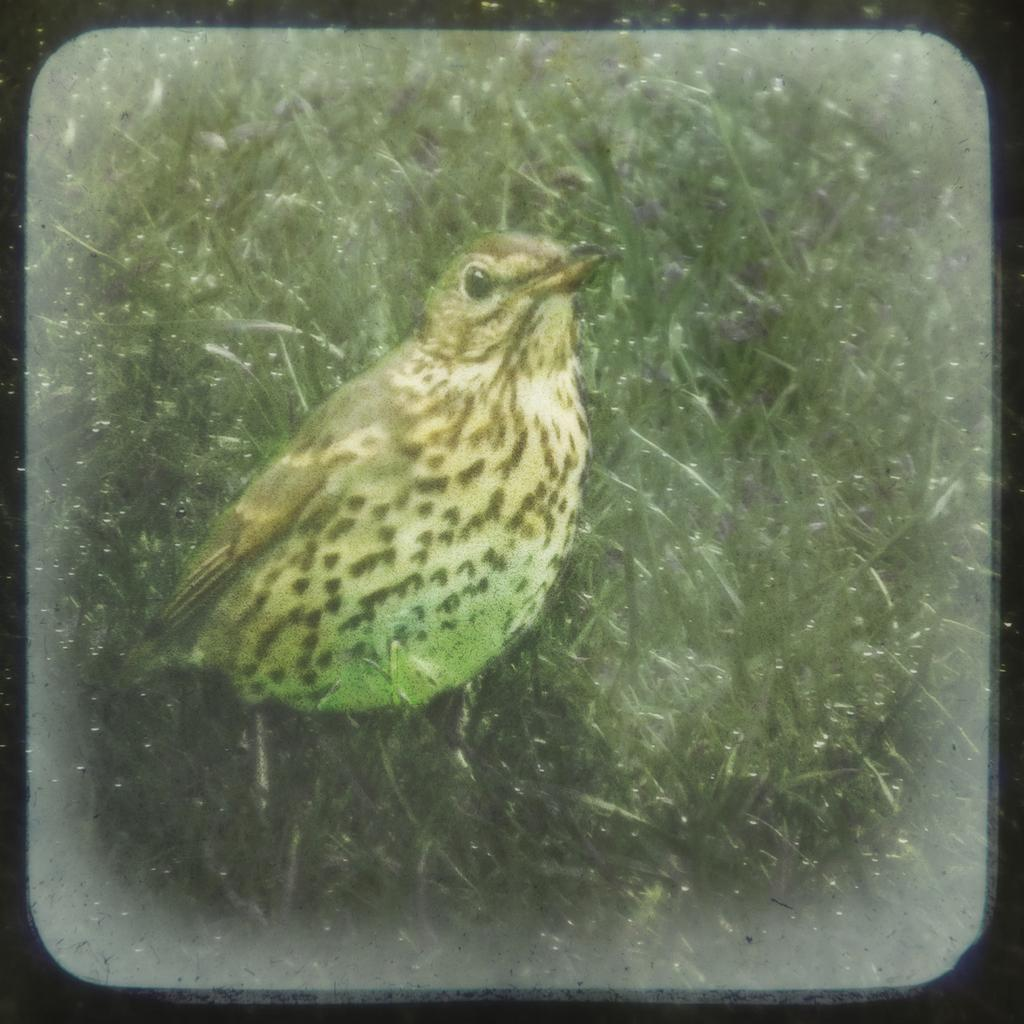What type of animal is present in the image? There is a bird in the image. Where is the bird located? The bird is on a grass field. What type of metal is the kettle made of in the image? There is no kettle present in the image. What is the aftermath of the bird's actions in the image? The image does not depict any actions by the bird, nor does it show any aftermath. 